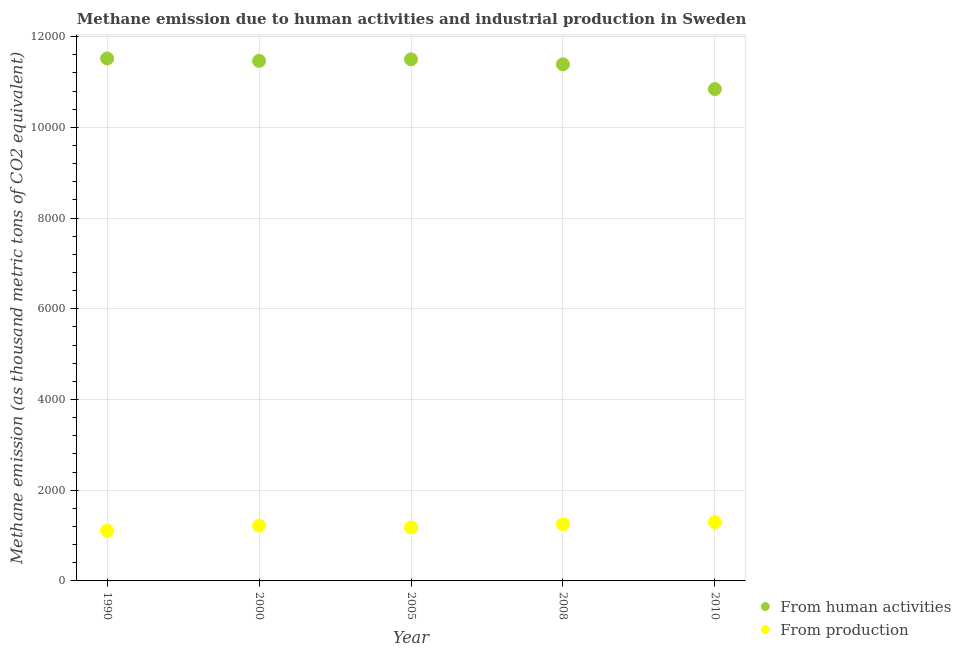Is the number of dotlines equal to the number of legend labels?
Your response must be concise. Yes. What is the amount of emissions generated from industries in 2008?
Make the answer very short. 1249.7. Across all years, what is the maximum amount of emissions from human activities?
Offer a terse response. 1.15e+04. Across all years, what is the minimum amount of emissions from human activities?
Provide a succinct answer. 1.08e+04. In which year was the amount of emissions from human activities maximum?
Your response must be concise. 1990. What is the total amount of emissions from human activities in the graph?
Provide a short and direct response. 5.67e+04. What is the difference between the amount of emissions from human activities in 1990 and that in 2005?
Your response must be concise. 18.4. What is the difference between the amount of emissions from human activities in 2000 and the amount of emissions generated from industries in 2005?
Your answer should be compact. 1.03e+04. What is the average amount of emissions generated from industries per year?
Provide a short and direct response. 1210.8. In the year 2005, what is the difference between the amount of emissions generated from industries and amount of emissions from human activities?
Your answer should be very brief. -1.03e+04. In how many years, is the amount of emissions from human activities greater than 6400 thousand metric tons?
Your answer should be very brief. 5. What is the ratio of the amount of emissions generated from industries in 1990 to that in 2010?
Your response must be concise. 0.85. Is the difference between the amount of emissions from human activities in 1990 and 2005 greater than the difference between the amount of emissions generated from industries in 1990 and 2005?
Keep it short and to the point. Yes. What is the difference between the highest and the second highest amount of emissions from human activities?
Your answer should be very brief. 18.4. What is the difference between the highest and the lowest amount of emissions from human activities?
Your response must be concise. 674.5. In how many years, is the amount of emissions generated from industries greater than the average amount of emissions generated from industries taken over all years?
Ensure brevity in your answer.  3. Is the sum of the amount of emissions from human activities in 2005 and 2008 greater than the maximum amount of emissions generated from industries across all years?
Keep it short and to the point. Yes. Is the amount of emissions from human activities strictly less than the amount of emissions generated from industries over the years?
Keep it short and to the point. No. How many years are there in the graph?
Offer a terse response. 5. Does the graph contain any zero values?
Offer a terse response. No. How many legend labels are there?
Your answer should be compact. 2. What is the title of the graph?
Your response must be concise. Methane emission due to human activities and industrial production in Sweden. What is the label or title of the X-axis?
Keep it short and to the point. Year. What is the label or title of the Y-axis?
Keep it short and to the point. Methane emission (as thousand metric tons of CO2 equivalent). What is the Methane emission (as thousand metric tons of CO2 equivalent) of From human activities in 1990?
Ensure brevity in your answer.  1.15e+04. What is the Methane emission (as thousand metric tons of CO2 equivalent) in From production in 1990?
Your response must be concise. 1108.1. What is the Methane emission (as thousand metric tons of CO2 equivalent) of From human activities in 2000?
Offer a terse response. 1.15e+04. What is the Methane emission (as thousand metric tons of CO2 equivalent) in From production in 2000?
Your response must be concise. 1219.3. What is the Methane emission (as thousand metric tons of CO2 equivalent) in From human activities in 2005?
Make the answer very short. 1.15e+04. What is the Methane emission (as thousand metric tons of CO2 equivalent) of From production in 2005?
Offer a terse response. 1179.4. What is the Methane emission (as thousand metric tons of CO2 equivalent) of From human activities in 2008?
Offer a very short reply. 1.14e+04. What is the Methane emission (as thousand metric tons of CO2 equivalent) in From production in 2008?
Offer a very short reply. 1249.7. What is the Methane emission (as thousand metric tons of CO2 equivalent) in From human activities in 2010?
Provide a succinct answer. 1.08e+04. What is the Methane emission (as thousand metric tons of CO2 equivalent) of From production in 2010?
Your answer should be very brief. 1297.5. Across all years, what is the maximum Methane emission (as thousand metric tons of CO2 equivalent) in From human activities?
Offer a terse response. 1.15e+04. Across all years, what is the maximum Methane emission (as thousand metric tons of CO2 equivalent) of From production?
Give a very brief answer. 1297.5. Across all years, what is the minimum Methane emission (as thousand metric tons of CO2 equivalent) of From human activities?
Give a very brief answer. 1.08e+04. Across all years, what is the minimum Methane emission (as thousand metric tons of CO2 equivalent) of From production?
Provide a short and direct response. 1108.1. What is the total Methane emission (as thousand metric tons of CO2 equivalent) in From human activities in the graph?
Keep it short and to the point. 5.67e+04. What is the total Methane emission (as thousand metric tons of CO2 equivalent) of From production in the graph?
Provide a succinct answer. 6054. What is the difference between the Methane emission (as thousand metric tons of CO2 equivalent) of From human activities in 1990 and that in 2000?
Provide a succinct answer. 53. What is the difference between the Methane emission (as thousand metric tons of CO2 equivalent) of From production in 1990 and that in 2000?
Make the answer very short. -111.2. What is the difference between the Methane emission (as thousand metric tons of CO2 equivalent) in From human activities in 1990 and that in 2005?
Provide a succinct answer. 18.4. What is the difference between the Methane emission (as thousand metric tons of CO2 equivalent) in From production in 1990 and that in 2005?
Provide a short and direct response. -71.3. What is the difference between the Methane emission (as thousand metric tons of CO2 equivalent) of From human activities in 1990 and that in 2008?
Offer a very short reply. 129.2. What is the difference between the Methane emission (as thousand metric tons of CO2 equivalent) of From production in 1990 and that in 2008?
Offer a terse response. -141.6. What is the difference between the Methane emission (as thousand metric tons of CO2 equivalent) of From human activities in 1990 and that in 2010?
Your response must be concise. 674.5. What is the difference between the Methane emission (as thousand metric tons of CO2 equivalent) in From production in 1990 and that in 2010?
Offer a very short reply. -189.4. What is the difference between the Methane emission (as thousand metric tons of CO2 equivalent) in From human activities in 2000 and that in 2005?
Offer a terse response. -34.6. What is the difference between the Methane emission (as thousand metric tons of CO2 equivalent) in From production in 2000 and that in 2005?
Keep it short and to the point. 39.9. What is the difference between the Methane emission (as thousand metric tons of CO2 equivalent) of From human activities in 2000 and that in 2008?
Provide a short and direct response. 76.2. What is the difference between the Methane emission (as thousand metric tons of CO2 equivalent) of From production in 2000 and that in 2008?
Offer a very short reply. -30.4. What is the difference between the Methane emission (as thousand metric tons of CO2 equivalent) in From human activities in 2000 and that in 2010?
Provide a short and direct response. 621.5. What is the difference between the Methane emission (as thousand metric tons of CO2 equivalent) of From production in 2000 and that in 2010?
Give a very brief answer. -78.2. What is the difference between the Methane emission (as thousand metric tons of CO2 equivalent) of From human activities in 2005 and that in 2008?
Your answer should be compact. 110.8. What is the difference between the Methane emission (as thousand metric tons of CO2 equivalent) of From production in 2005 and that in 2008?
Your response must be concise. -70.3. What is the difference between the Methane emission (as thousand metric tons of CO2 equivalent) in From human activities in 2005 and that in 2010?
Provide a short and direct response. 656.1. What is the difference between the Methane emission (as thousand metric tons of CO2 equivalent) of From production in 2005 and that in 2010?
Your answer should be compact. -118.1. What is the difference between the Methane emission (as thousand metric tons of CO2 equivalent) of From human activities in 2008 and that in 2010?
Ensure brevity in your answer.  545.3. What is the difference between the Methane emission (as thousand metric tons of CO2 equivalent) of From production in 2008 and that in 2010?
Provide a succinct answer. -47.8. What is the difference between the Methane emission (as thousand metric tons of CO2 equivalent) of From human activities in 1990 and the Methane emission (as thousand metric tons of CO2 equivalent) of From production in 2000?
Your answer should be compact. 1.03e+04. What is the difference between the Methane emission (as thousand metric tons of CO2 equivalent) of From human activities in 1990 and the Methane emission (as thousand metric tons of CO2 equivalent) of From production in 2005?
Your answer should be very brief. 1.03e+04. What is the difference between the Methane emission (as thousand metric tons of CO2 equivalent) of From human activities in 1990 and the Methane emission (as thousand metric tons of CO2 equivalent) of From production in 2008?
Your answer should be compact. 1.03e+04. What is the difference between the Methane emission (as thousand metric tons of CO2 equivalent) of From human activities in 1990 and the Methane emission (as thousand metric tons of CO2 equivalent) of From production in 2010?
Make the answer very short. 1.02e+04. What is the difference between the Methane emission (as thousand metric tons of CO2 equivalent) in From human activities in 2000 and the Methane emission (as thousand metric tons of CO2 equivalent) in From production in 2005?
Offer a very short reply. 1.03e+04. What is the difference between the Methane emission (as thousand metric tons of CO2 equivalent) of From human activities in 2000 and the Methane emission (as thousand metric tons of CO2 equivalent) of From production in 2008?
Your response must be concise. 1.02e+04. What is the difference between the Methane emission (as thousand metric tons of CO2 equivalent) of From human activities in 2000 and the Methane emission (as thousand metric tons of CO2 equivalent) of From production in 2010?
Keep it short and to the point. 1.02e+04. What is the difference between the Methane emission (as thousand metric tons of CO2 equivalent) in From human activities in 2005 and the Methane emission (as thousand metric tons of CO2 equivalent) in From production in 2008?
Give a very brief answer. 1.03e+04. What is the difference between the Methane emission (as thousand metric tons of CO2 equivalent) of From human activities in 2005 and the Methane emission (as thousand metric tons of CO2 equivalent) of From production in 2010?
Your answer should be very brief. 1.02e+04. What is the difference between the Methane emission (as thousand metric tons of CO2 equivalent) of From human activities in 2008 and the Methane emission (as thousand metric tons of CO2 equivalent) of From production in 2010?
Make the answer very short. 1.01e+04. What is the average Methane emission (as thousand metric tons of CO2 equivalent) in From human activities per year?
Provide a short and direct response. 1.13e+04. What is the average Methane emission (as thousand metric tons of CO2 equivalent) of From production per year?
Your answer should be very brief. 1210.8. In the year 1990, what is the difference between the Methane emission (as thousand metric tons of CO2 equivalent) in From human activities and Methane emission (as thousand metric tons of CO2 equivalent) in From production?
Offer a terse response. 1.04e+04. In the year 2000, what is the difference between the Methane emission (as thousand metric tons of CO2 equivalent) of From human activities and Methane emission (as thousand metric tons of CO2 equivalent) of From production?
Give a very brief answer. 1.02e+04. In the year 2005, what is the difference between the Methane emission (as thousand metric tons of CO2 equivalent) in From human activities and Methane emission (as thousand metric tons of CO2 equivalent) in From production?
Keep it short and to the point. 1.03e+04. In the year 2008, what is the difference between the Methane emission (as thousand metric tons of CO2 equivalent) of From human activities and Methane emission (as thousand metric tons of CO2 equivalent) of From production?
Your answer should be compact. 1.01e+04. In the year 2010, what is the difference between the Methane emission (as thousand metric tons of CO2 equivalent) of From human activities and Methane emission (as thousand metric tons of CO2 equivalent) of From production?
Keep it short and to the point. 9547.3. What is the ratio of the Methane emission (as thousand metric tons of CO2 equivalent) in From human activities in 1990 to that in 2000?
Provide a short and direct response. 1. What is the ratio of the Methane emission (as thousand metric tons of CO2 equivalent) in From production in 1990 to that in 2000?
Your answer should be very brief. 0.91. What is the ratio of the Methane emission (as thousand metric tons of CO2 equivalent) in From production in 1990 to that in 2005?
Ensure brevity in your answer.  0.94. What is the ratio of the Methane emission (as thousand metric tons of CO2 equivalent) of From human activities in 1990 to that in 2008?
Provide a short and direct response. 1.01. What is the ratio of the Methane emission (as thousand metric tons of CO2 equivalent) of From production in 1990 to that in 2008?
Ensure brevity in your answer.  0.89. What is the ratio of the Methane emission (as thousand metric tons of CO2 equivalent) of From human activities in 1990 to that in 2010?
Your answer should be very brief. 1.06. What is the ratio of the Methane emission (as thousand metric tons of CO2 equivalent) in From production in 1990 to that in 2010?
Make the answer very short. 0.85. What is the ratio of the Methane emission (as thousand metric tons of CO2 equivalent) of From production in 2000 to that in 2005?
Your answer should be compact. 1.03. What is the ratio of the Methane emission (as thousand metric tons of CO2 equivalent) in From production in 2000 to that in 2008?
Keep it short and to the point. 0.98. What is the ratio of the Methane emission (as thousand metric tons of CO2 equivalent) in From human activities in 2000 to that in 2010?
Provide a succinct answer. 1.06. What is the ratio of the Methane emission (as thousand metric tons of CO2 equivalent) in From production in 2000 to that in 2010?
Your answer should be compact. 0.94. What is the ratio of the Methane emission (as thousand metric tons of CO2 equivalent) in From human activities in 2005 to that in 2008?
Your response must be concise. 1.01. What is the ratio of the Methane emission (as thousand metric tons of CO2 equivalent) of From production in 2005 to that in 2008?
Keep it short and to the point. 0.94. What is the ratio of the Methane emission (as thousand metric tons of CO2 equivalent) in From human activities in 2005 to that in 2010?
Your response must be concise. 1.06. What is the ratio of the Methane emission (as thousand metric tons of CO2 equivalent) in From production in 2005 to that in 2010?
Make the answer very short. 0.91. What is the ratio of the Methane emission (as thousand metric tons of CO2 equivalent) in From human activities in 2008 to that in 2010?
Offer a terse response. 1.05. What is the ratio of the Methane emission (as thousand metric tons of CO2 equivalent) of From production in 2008 to that in 2010?
Provide a succinct answer. 0.96. What is the difference between the highest and the second highest Methane emission (as thousand metric tons of CO2 equivalent) of From human activities?
Keep it short and to the point. 18.4. What is the difference between the highest and the second highest Methane emission (as thousand metric tons of CO2 equivalent) of From production?
Give a very brief answer. 47.8. What is the difference between the highest and the lowest Methane emission (as thousand metric tons of CO2 equivalent) in From human activities?
Offer a very short reply. 674.5. What is the difference between the highest and the lowest Methane emission (as thousand metric tons of CO2 equivalent) in From production?
Offer a very short reply. 189.4. 